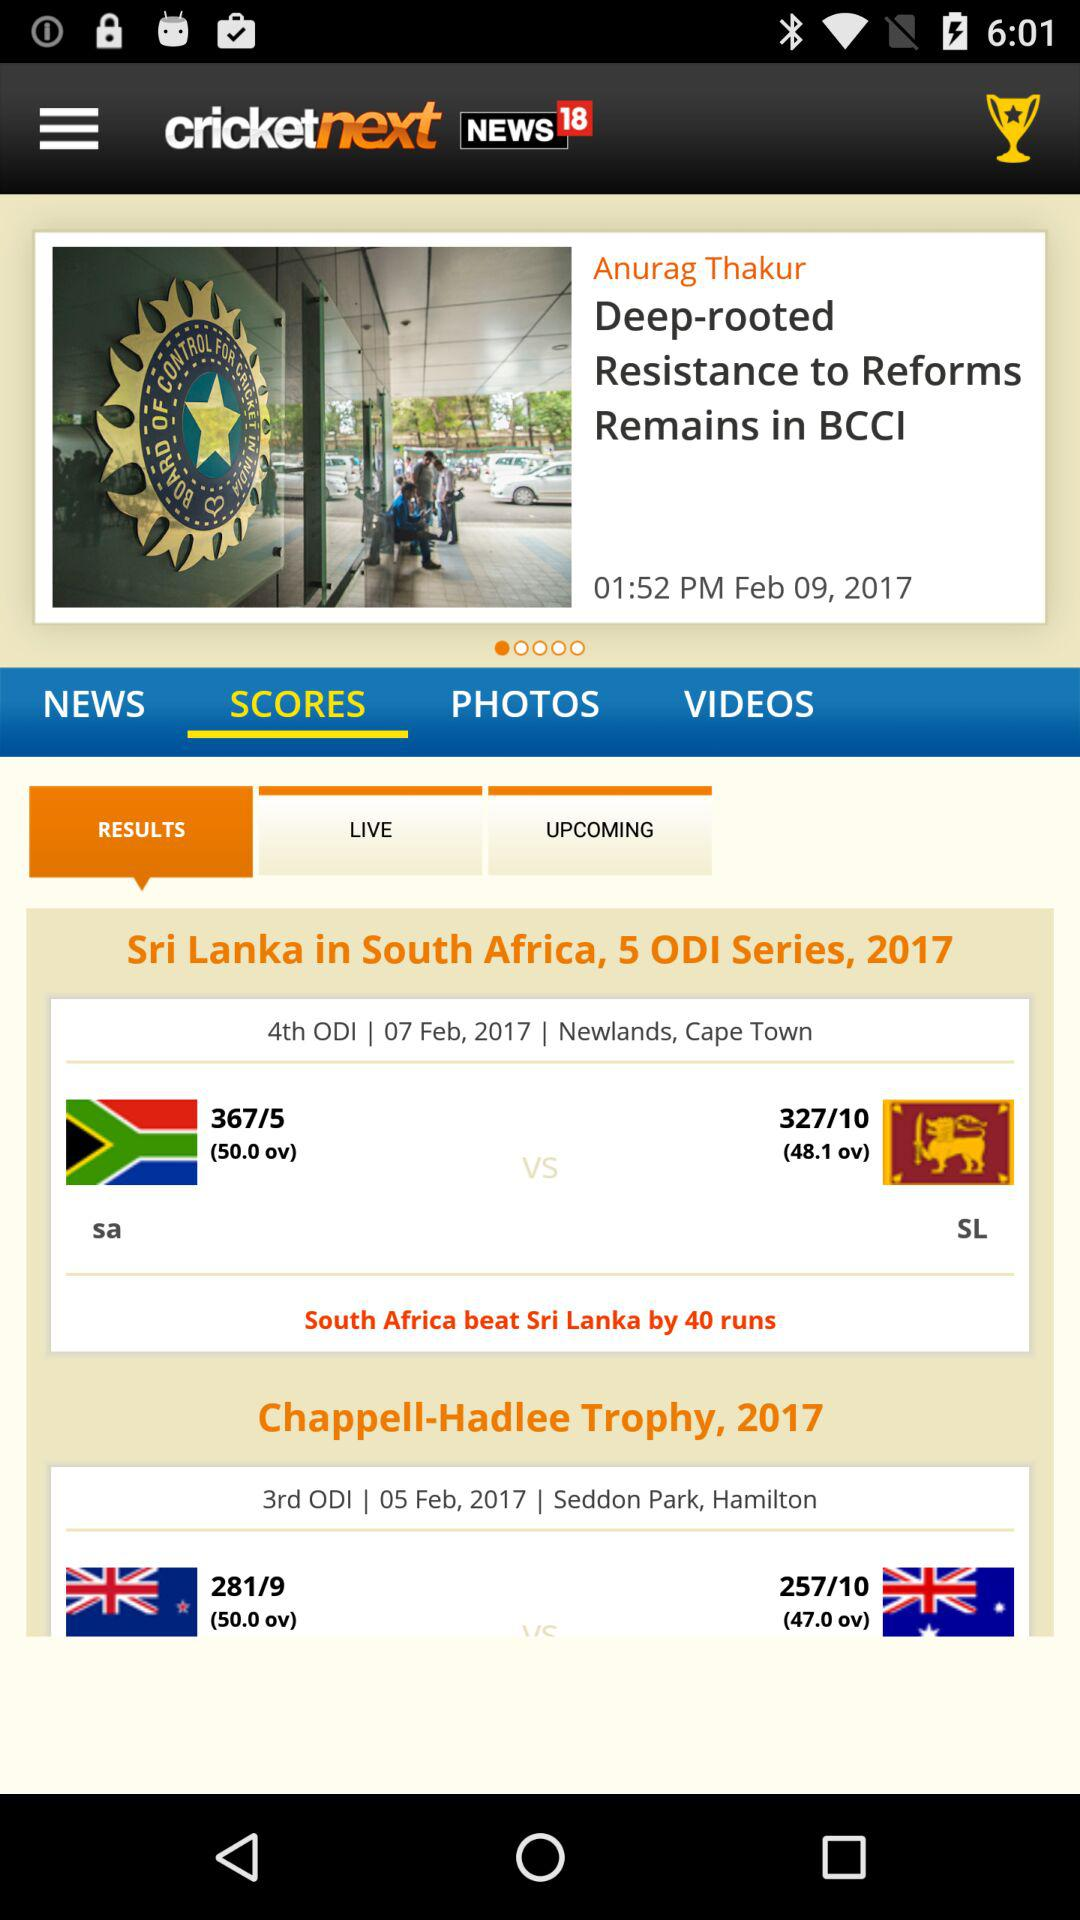In how many overs did "Sri Lanka" score 327? "Sri Lanka" scored 327 in 48.1 overs. 